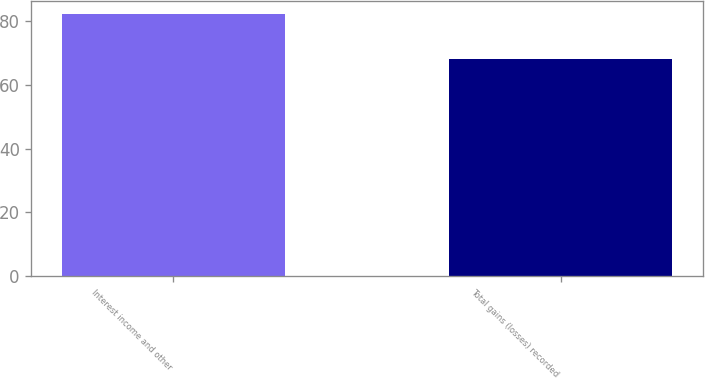Convert chart to OTSL. <chart><loc_0><loc_0><loc_500><loc_500><bar_chart><fcel>Interest income and other<fcel>Total gains (losses) recorded<nl><fcel>82<fcel>68<nl></chart> 